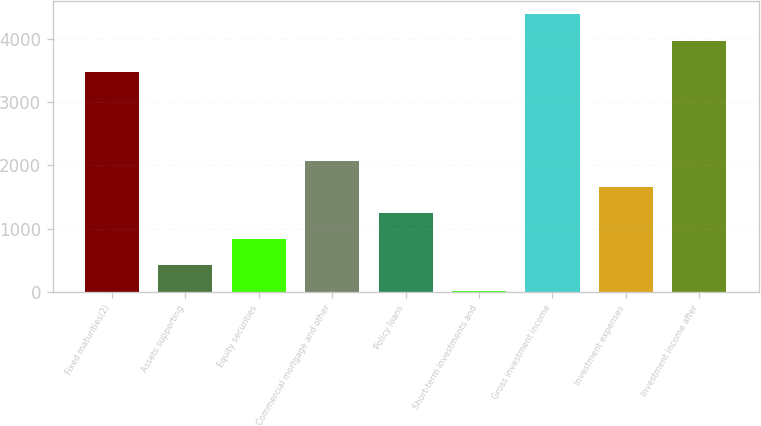Convert chart to OTSL. <chart><loc_0><loc_0><loc_500><loc_500><bar_chart><fcel>Fixed maturities(2)<fcel>Assets supporting<fcel>Equity securities<fcel>Commercial mortgage and other<fcel>Policy loans<fcel>Short-term investments and<fcel>Gross investment income<fcel>Investment expenses<fcel>Investment income after<nl><fcel>3472<fcel>421.4<fcel>833.8<fcel>2071<fcel>1246.2<fcel>9<fcel>4380.4<fcel>1658.6<fcel>3968<nl></chart> 